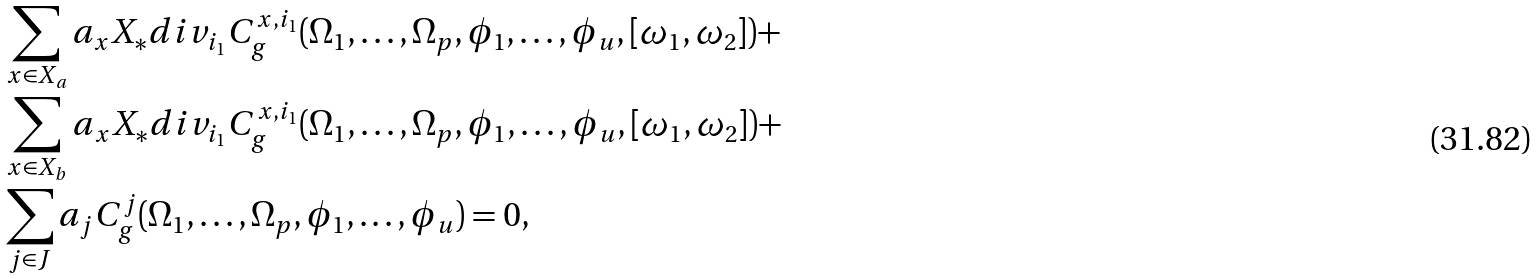<formula> <loc_0><loc_0><loc_500><loc_500>& \sum _ { x \in X _ { a } } a _ { x } X _ { * } d i v _ { i _ { 1 } } C ^ { x , i _ { 1 } } _ { g } ( \Omega _ { 1 } , \dots , \Omega _ { p } , \phi _ { 1 } , \dots , \phi _ { u } , [ \omega _ { 1 } , \omega _ { 2 } ] ) + \\ & \sum _ { x \in X _ { b } } a _ { x } X _ { * } d i v _ { i _ { 1 } } C ^ { x , i _ { 1 } } _ { g } ( \Omega _ { 1 } , \dots , \Omega _ { p } , \phi _ { 1 } , \dots , \phi _ { u } , [ \omega _ { 1 } , \omega _ { 2 } ] ) + \\ & \sum _ { j \in J } a _ { j } C ^ { j } _ { g } ( \Omega _ { 1 } , \dots , \Omega _ { p } , \phi _ { 1 } , \dots , \phi _ { u } ) = 0 ,</formula> 